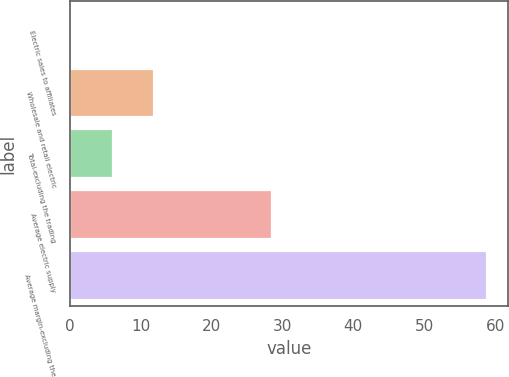Convert chart to OTSL. <chart><loc_0><loc_0><loc_500><loc_500><bar_chart><fcel>Electric sales to affiliates<fcel>Wholesale and retail electric<fcel>Total-excluding the trading<fcel>Average electric supply<fcel>Average margin-excluding the<nl><fcel>0.2<fcel>11.94<fcel>6.07<fcel>28.5<fcel>58.9<nl></chart> 